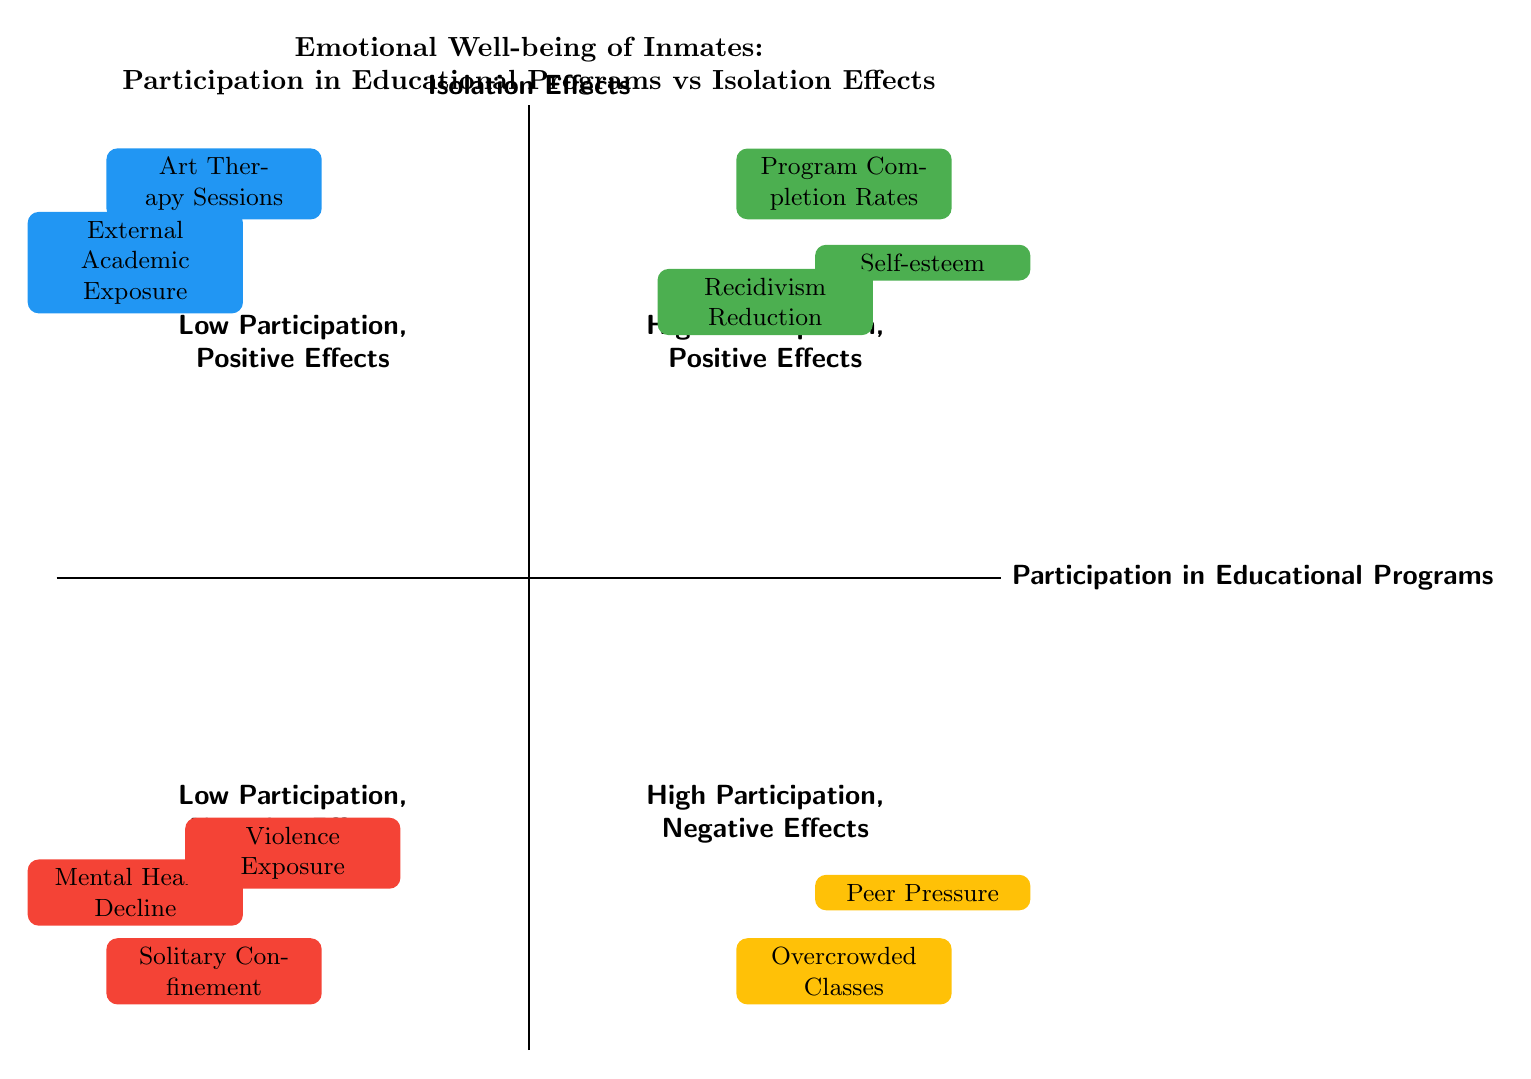What are the positive effects associated with high participation? In the quadrant titled "High Participation, Positive Effects," there are three elements: Program Completion Rates, Self-esteem, and Recidivism Reduction, all of which indicate beneficial outcomes for inmates involved in educational programs.
Answer: Program Completion Rates, Self-esteem, Recidivism Reduction How many elements are in the "Low Participation, Negative Effects" quadrant? In reviewing the "Low Participation, Negative Effects" quadrant, you find three elements listed: Solitary Confinement, Mental Health Decline, and Violence Exposure, which totals to three elements.
Answer: 3 What effect does overcrowded classes have according to the chart? Within the "High Participation, Negative Effects" quadrant, the element "Overcrowded Classes" is noted, indicating it causes stress due to inadequate teacher-to-student ratios.
Answer: Stress Which quadrant includes art therapy sessions? The "Low Participation, Positive Effects" quadrant contains the element "Art Therapy Sessions," which is specifically listed there.
Answer: Low Participation, Positive Effects What is the primary negative effect associated with solitary confinement? In the "Low Participation, Negative Effects" quadrant, the element "Solitary Confinement" is associated with the negative effect of "Extended periods without human contact," indicating a severe impact on well-being.
Answer: Extended periods without human contact What is the relationship between "Peer Pressure" and participation in educational programs? "Peer Pressure" is located in the "High Participation, Negative Effects" quadrant, which suggests that even with high participation in educational programs, there can be negative social dynamics that lead to coercive behavior.
Answer: Negative social dynamics Which element sources its data from the National Institute of Justice? The element "Peer Pressure," found in the "High Participation, Negative Effects" quadrant, attributes its data source to the National Institute of Justice.
Answer: Peer Pressure How does external academic exposure relate to inmates' participation in programs? "External Academic Exposure," located in the "Low Participation, Positive Effects" quadrant, implies that even with low participation in structured programs, inmates can benefit from access to academic materials.
Answer: Access to academic materials 